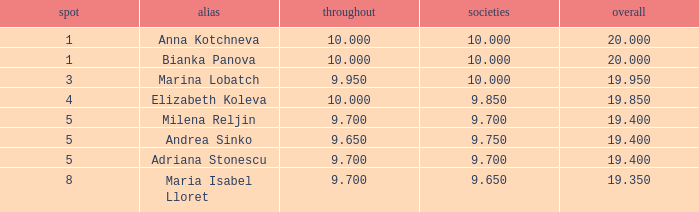What is the highest total that has andrea sinko as the name, with an all around greater than 9.65? None. 